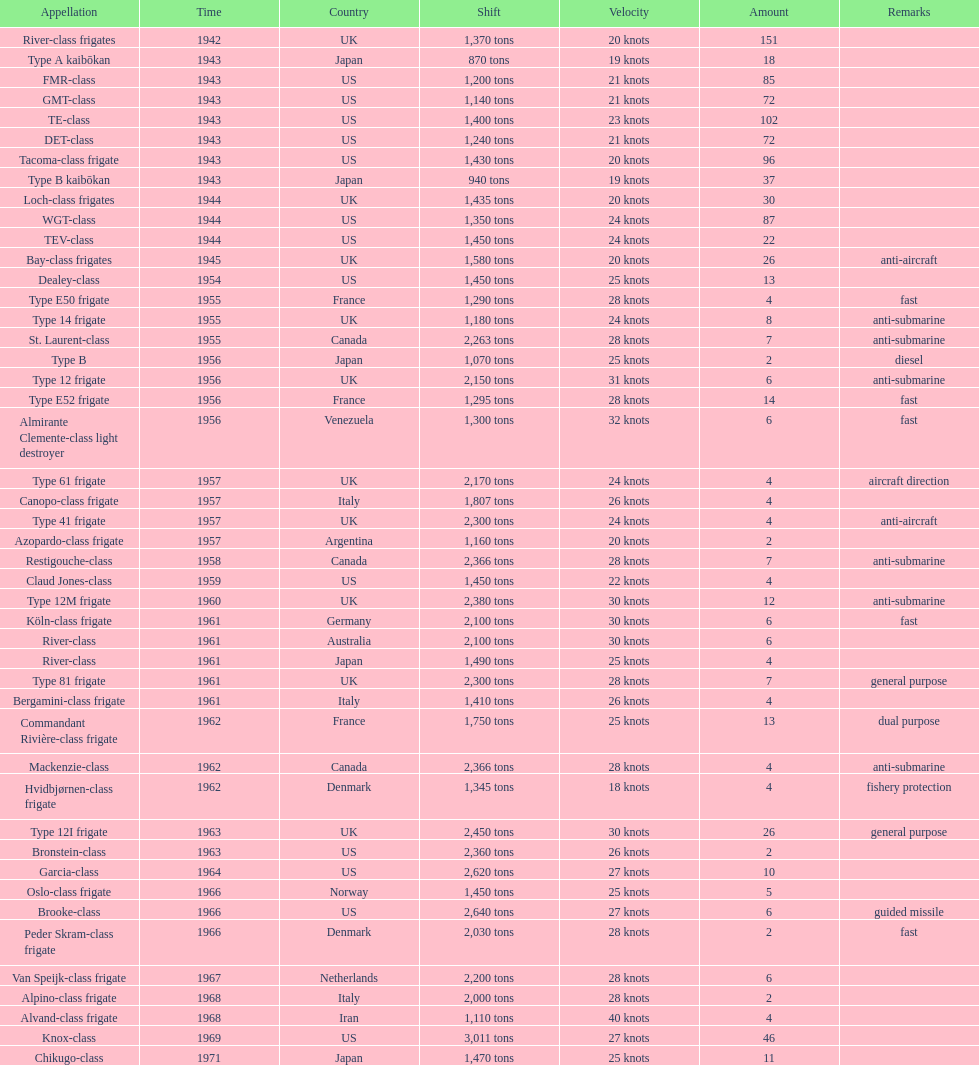How many consecutive escorts were in 1943? 7. 